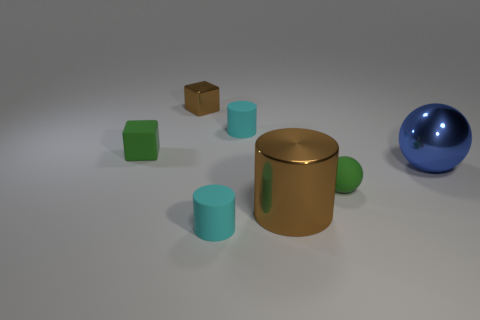There is a brown metallic object behind the brown cylinder; does it have the same size as the green matte object behind the blue metal sphere?
Make the answer very short. Yes. The brown metal object that is to the left of the rubber cylinder behind the tiny sphere is what shape?
Your answer should be compact. Cube. Is the number of small brown things to the right of the metal ball the same as the number of purple metal objects?
Your answer should be compact. Yes. What is the material of the brown thing that is in front of the cyan rubber cylinder right of the cyan matte cylinder in front of the large shiny sphere?
Offer a very short reply. Metal. Is there a yellow metallic cube that has the same size as the blue sphere?
Your answer should be compact. No. There is a large brown object; what shape is it?
Ensure brevity in your answer.  Cylinder. What number of balls are either tiny metallic objects or tiny rubber objects?
Keep it short and to the point. 1. Are there an equal number of big brown metal cylinders that are in front of the large blue object and large brown things to the left of the tiny sphere?
Keep it short and to the point. Yes. How many green matte things are behind the brown shiny thing left of the cyan matte thing that is in front of the small green ball?
Ensure brevity in your answer.  0. What is the shape of the metallic object that is the same color as the shiny cylinder?
Your answer should be compact. Cube. 